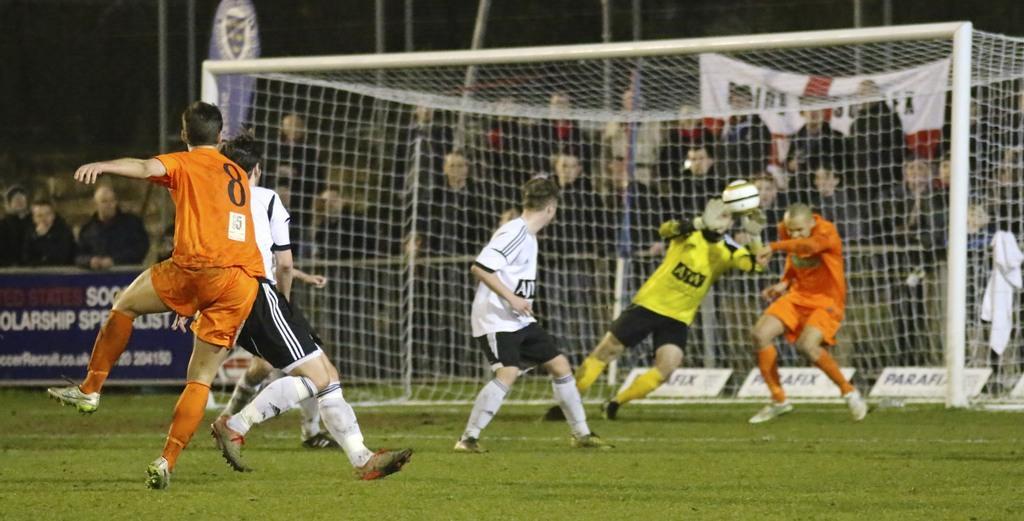Please provide a concise description of this image. In the image there players were playing football in the ground and around the ground the spectators were sitting and watching the match. 